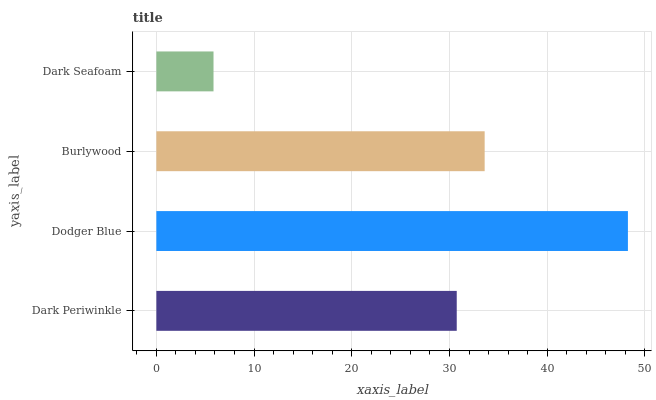Is Dark Seafoam the minimum?
Answer yes or no. Yes. Is Dodger Blue the maximum?
Answer yes or no. Yes. Is Burlywood the minimum?
Answer yes or no. No. Is Burlywood the maximum?
Answer yes or no. No. Is Dodger Blue greater than Burlywood?
Answer yes or no. Yes. Is Burlywood less than Dodger Blue?
Answer yes or no. Yes. Is Burlywood greater than Dodger Blue?
Answer yes or no. No. Is Dodger Blue less than Burlywood?
Answer yes or no. No. Is Burlywood the high median?
Answer yes or no. Yes. Is Dark Periwinkle the low median?
Answer yes or no. Yes. Is Dodger Blue the high median?
Answer yes or no. No. Is Burlywood the low median?
Answer yes or no. No. 